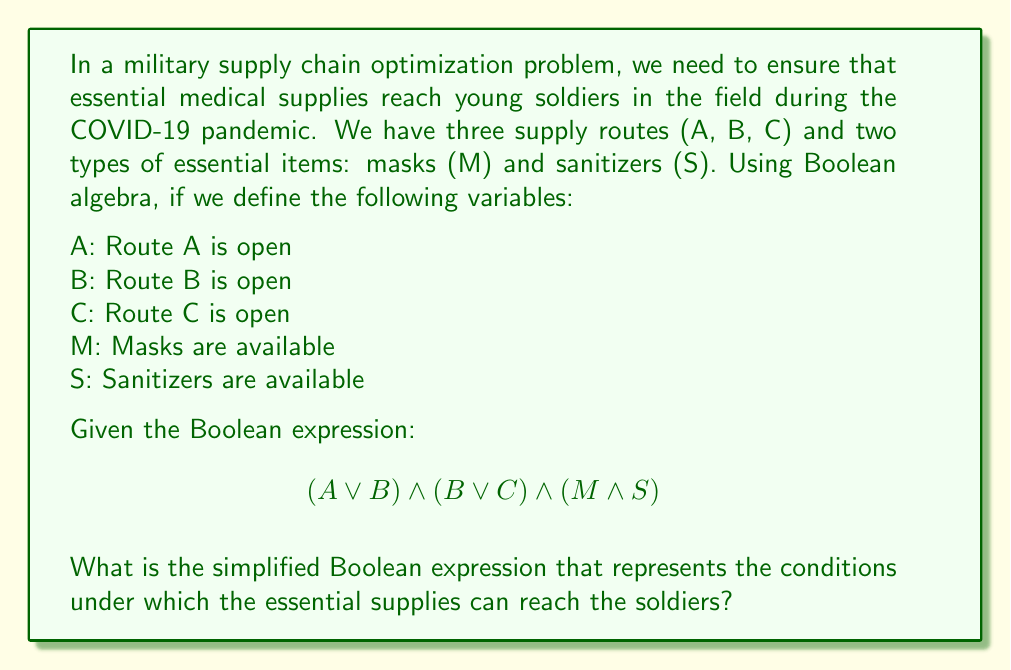Could you help me with this problem? Let's approach this step-by-step:

1) First, let's examine the given Boolean expression:
   $$(A \lor B) \land (B \lor C) \land (M \land S)$$

2) We can use the distributive law to simplify the first two terms:
   $$(A \lor B) \land (B \lor C) = (A \land B) \lor (A \land C) \lor (B \land B) \lor (B \land C)$$

3) Simplify $B \land B$ to just $B$:
   $$(A \land B) \lor (A \land C) \lor B \lor (B \land C)$$

4) We can further simplify this using the absorption law:
   $B \lor (A \land B) = B$
   $B \lor (B \land C) = B$

5) After applying these simplifications, we get:
   $$(A \land C) \lor B$$

6) Now, let's combine this with the last term $(M \land S)$:
   $((A \land C) \lor B) \land (M \land S)$

7) Using the distributive law again:
   $((A \land C) \land (M \land S)) \lor (B \land M \land S)$

This is our final simplified expression.
Answer: $((A \land C) \land (M \land S)) \lor (B \land M \land S)$ 